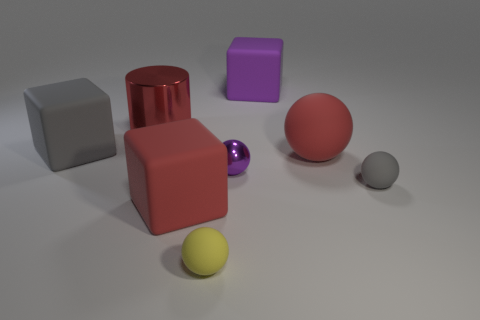Is the size of the gray ball the same as the matte object behind the gray block?
Make the answer very short. No. There is another shiny object that is the same size as the yellow object; what color is it?
Your response must be concise. Purple. What is the size of the red sphere?
Your response must be concise. Large. Is the tiny thing to the left of the purple shiny object made of the same material as the tiny purple thing?
Your answer should be compact. No. Is the shape of the yellow object the same as the tiny gray object?
Give a very brief answer. Yes. There is a tiny object in front of the large red matte thing that is on the left side of the matte block that is right of the red cube; what is its shape?
Your answer should be compact. Sphere. Do the gray thing that is behind the tiny metallic sphere and the big red thing that is behind the gray rubber block have the same shape?
Give a very brief answer. No. Is there a big sphere that has the same material as the tiny purple object?
Ensure brevity in your answer.  No. There is a metallic thing that is in front of the big red thing that is right of the purple object on the right side of the small metallic sphere; what is its color?
Your answer should be very brief. Purple. Do the tiny purple thing that is right of the tiny yellow object and the big red thing that is right of the yellow rubber object have the same material?
Provide a succinct answer. No. 